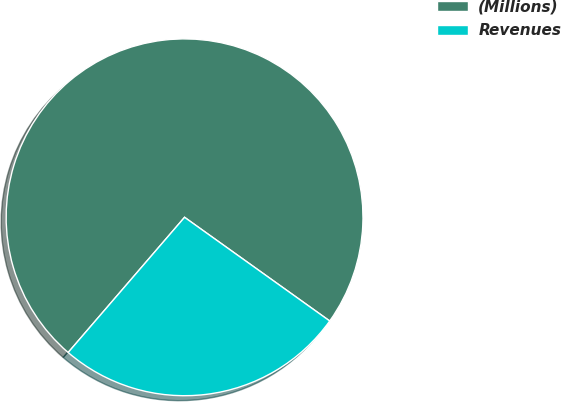<chart> <loc_0><loc_0><loc_500><loc_500><pie_chart><fcel>(Millions)<fcel>Revenues<nl><fcel>73.56%<fcel>26.44%<nl></chart> 